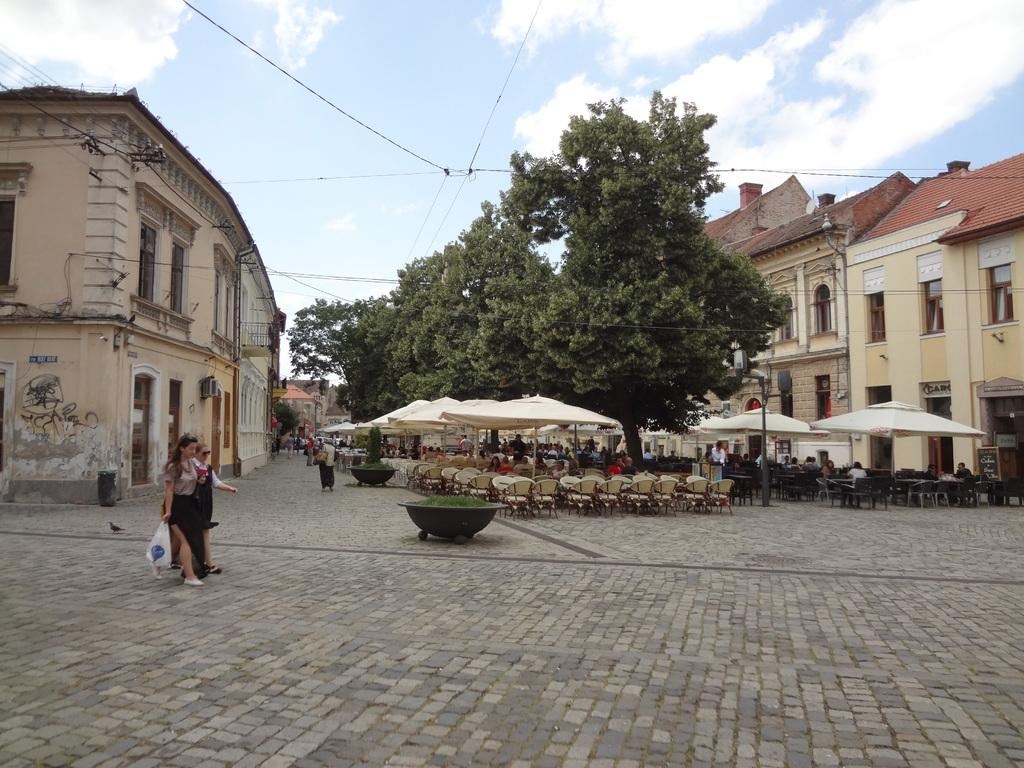Who or what can be seen in the image? There are people in the image. What type of structures are visible in the image? There are buildings with windows in the image. What type of furniture is present in the image? There are chairs in the image. What type of temporary shelters can be seen in the image? There are tents in the image. What type of natural elements are present in the image? There are trees in the image. What is visible in the background of the image? The sky is visible in the background of the image. What is the price of the gun in the image? There is no gun present in the image, so it is not possible to determine its price. 